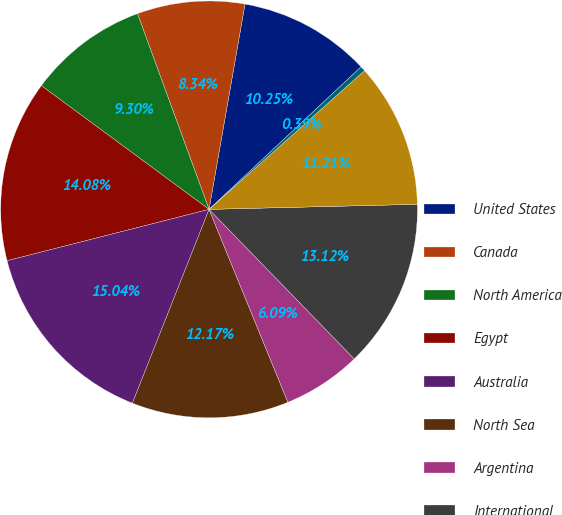Convert chart. <chart><loc_0><loc_0><loc_500><loc_500><pie_chart><fcel>United States<fcel>Canada<fcel>North America<fcel>Egypt<fcel>Australia<fcel>North Sea<fcel>Argentina<fcel>International<fcel>Total (1)<fcel>Total (2)<nl><fcel>10.25%<fcel>8.34%<fcel>9.3%<fcel>14.08%<fcel>15.04%<fcel>12.17%<fcel>6.09%<fcel>13.12%<fcel>11.21%<fcel>0.39%<nl></chart> 